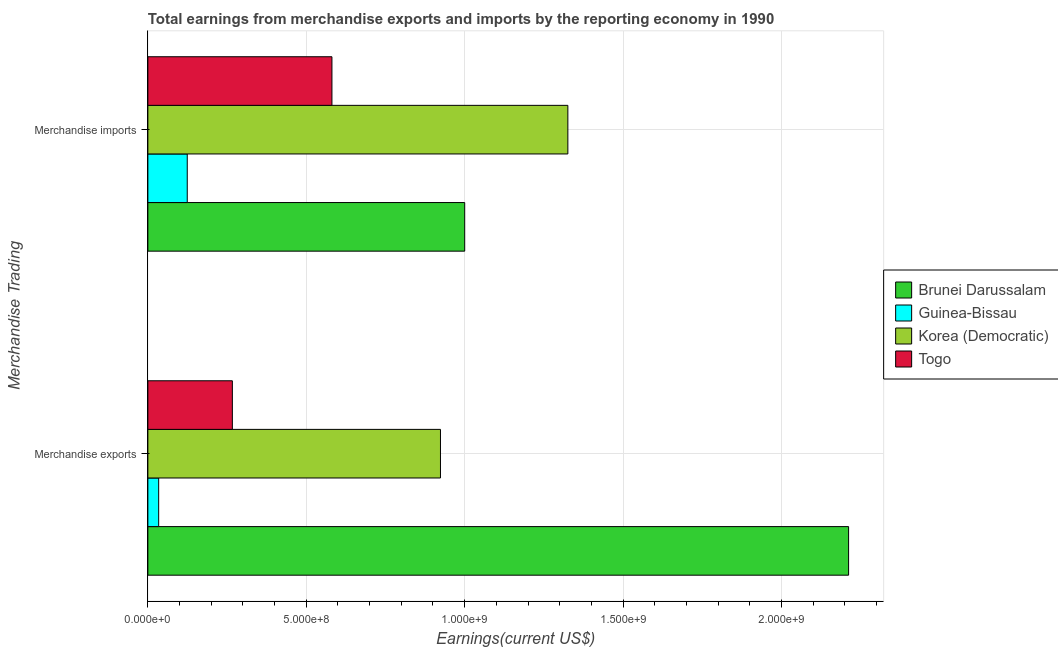How many groups of bars are there?
Provide a short and direct response. 2. Are the number of bars per tick equal to the number of legend labels?
Your answer should be compact. Yes. Are the number of bars on each tick of the Y-axis equal?
Give a very brief answer. Yes. How many bars are there on the 2nd tick from the top?
Your response must be concise. 4. How many bars are there on the 1st tick from the bottom?
Provide a short and direct response. 4. What is the earnings from merchandise exports in Togo?
Provide a succinct answer. 2.67e+08. Across all countries, what is the maximum earnings from merchandise exports?
Give a very brief answer. 2.21e+09. Across all countries, what is the minimum earnings from merchandise exports?
Provide a succinct answer. 3.41e+07. In which country was the earnings from merchandise exports maximum?
Your answer should be very brief. Brunei Darussalam. In which country was the earnings from merchandise exports minimum?
Give a very brief answer. Guinea-Bissau. What is the total earnings from merchandise exports in the graph?
Your answer should be very brief. 3.44e+09. What is the difference between the earnings from merchandise imports in Togo and that in Korea (Democratic)?
Keep it short and to the point. -7.45e+08. What is the difference between the earnings from merchandise imports in Guinea-Bissau and the earnings from merchandise exports in Brunei Darussalam?
Keep it short and to the point. -2.09e+09. What is the average earnings from merchandise imports per country?
Your response must be concise. 7.58e+08. What is the difference between the earnings from merchandise imports and earnings from merchandise exports in Brunei Darussalam?
Ensure brevity in your answer.  -1.21e+09. What is the ratio of the earnings from merchandise exports in Brunei Darussalam to that in Korea (Democratic)?
Your answer should be compact. 2.39. Is the earnings from merchandise imports in Brunei Darussalam less than that in Togo?
Keep it short and to the point. No. In how many countries, is the earnings from merchandise imports greater than the average earnings from merchandise imports taken over all countries?
Your answer should be compact. 2. What does the 4th bar from the top in Merchandise imports represents?
Provide a succinct answer. Brunei Darussalam. What does the 1st bar from the bottom in Merchandise exports represents?
Ensure brevity in your answer.  Brunei Darussalam. How many bars are there?
Ensure brevity in your answer.  8. Where does the legend appear in the graph?
Keep it short and to the point. Center right. How many legend labels are there?
Give a very brief answer. 4. What is the title of the graph?
Ensure brevity in your answer.  Total earnings from merchandise exports and imports by the reporting economy in 1990. Does "Serbia" appear as one of the legend labels in the graph?
Provide a succinct answer. No. What is the label or title of the X-axis?
Offer a terse response. Earnings(current US$). What is the label or title of the Y-axis?
Offer a very short reply. Merchandise Trading. What is the Earnings(current US$) of Brunei Darussalam in Merchandise exports?
Your response must be concise. 2.21e+09. What is the Earnings(current US$) in Guinea-Bissau in Merchandise exports?
Make the answer very short. 3.41e+07. What is the Earnings(current US$) of Korea (Democratic) in Merchandise exports?
Offer a terse response. 9.24e+08. What is the Earnings(current US$) in Togo in Merchandise exports?
Provide a succinct answer. 2.67e+08. What is the Earnings(current US$) of Brunei Darussalam in Merchandise imports?
Offer a terse response. 1.00e+09. What is the Earnings(current US$) of Guinea-Bissau in Merchandise imports?
Give a very brief answer. 1.24e+08. What is the Earnings(current US$) in Korea (Democratic) in Merchandise imports?
Your response must be concise. 1.33e+09. What is the Earnings(current US$) in Togo in Merchandise imports?
Your response must be concise. 5.81e+08. Across all Merchandise Trading, what is the maximum Earnings(current US$) in Brunei Darussalam?
Provide a short and direct response. 2.21e+09. Across all Merchandise Trading, what is the maximum Earnings(current US$) in Guinea-Bissau?
Keep it short and to the point. 1.24e+08. Across all Merchandise Trading, what is the maximum Earnings(current US$) of Korea (Democratic)?
Provide a succinct answer. 1.33e+09. Across all Merchandise Trading, what is the maximum Earnings(current US$) in Togo?
Offer a very short reply. 5.81e+08. Across all Merchandise Trading, what is the minimum Earnings(current US$) of Brunei Darussalam?
Make the answer very short. 1.00e+09. Across all Merchandise Trading, what is the minimum Earnings(current US$) of Guinea-Bissau?
Your answer should be compact. 3.41e+07. Across all Merchandise Trading, what is the minimum Earnings(current US$) of Korea (Democratic)?
Ensure brevity in your answer.  9.24e+08. Across all Merchandise Trading, what is the minimum Earnings(current US$) of Togo?
Offer a very short reply. 2.67e+08. What is the total Earnings(current US$) of Brunei Darussalam in the graph?
Your answer should be very brief. 3.21e+09. What is the total Earnings(current US$) of Guinea-Bissau in the graph?
Provide a short and direct response. 1.58e+08. What is the total Earnings(current US$) in Korea (Democratic) in the graph?
Give a very brief answer. 2.25e+09. What is the total Earnings(current US$) in Togo in the graph?
Make the answer very short. 8.48e+08. What is the difference between the Earnings(current US$) of Brunei Darussalam in Merchandise exports and that in Merchandise imports?
Give a very brief answer. 1.21e+09. What is the difference between the Earnings(current US$) of Guinea-Bissau in Merchandise exports and that in Merchandise imports?
Give a very brief answer. -9.02e+07. What is the difference between the Earnings(current US$) in Korea (Democratic) in Merchandise exports and that in Merchandise imports?
Keep it short and to the point. -4.02e+08. What is the difference between the Earnings(current US$) of Togo in Merchandise exports and that in Merchandise imports?
Provide a succinct answer. -3.14e+08. What is the difference between the Earnings(current US$) in Brunei Darussalam in Merchandise exports and the Earnings(current US$) in Guinea-Bissau in Merchandise imports?
Provide a succinct answer. 2.09e+09. What is the difference between the Earnings(current US$) of Brunei Darussalam in Merchandise exports and the Earnings(current US$) of Korea (Democratic) in Merchandise imports?
Your answer should be compact. 8.86e+08. What is the difference between the Earnings(current US$) in Brunei Darussalam in Merchandise exports and the Earnings(current US$) in Togo in Merchandise imports?
Your answer should be compact. 1.63e+09. What is the difference between the Earnings(current US$) in Guinea-Bissau in Merchandise exports and the Earnings(current US$) in Korea (Democratic) in Merchandise imports?
Give a very brief answer. -1.29e+09. What is the difference between the Earnings(current US$) of Guinea-Bissau in Merchandise exports and the Earnings(current US$) of Togo in Merchandise imports?
Keep it short and to the point. -5.47e+08. What is the difference between the Earnings(current US$) of Korea (Democratic) in Merchandise exports and the Earnings(current US$) of Togo in Merchandise imports?
Your response must be concise. 3.43e+08. What is the average Earnings(current US$) in Brunei Darussalam per Merchandise Trading?
Your answer should be compact. 1.61e+09. What is the average Earnings(current US$) in Guinea-Bissau per Merchandise Trading?
Give a very brief answer. 7.92e+07. What is the average Earnings(current US$) in Korea (Democratic) per Merchandise Trading?
Offer a very short reply. 1.12e+09. What is the average Earnings(current US$) in Togo per Merchandise Trading?
Provide a succinct answer. 4.24e+08. What is the difference between the Earnings(current US$) of Brunei Darussalam and Earnings(current US$) of Guinea-Bissau in Merchandise exports?
Offer a very short reply. 2.18e+09. What is the difference between the Earnings(current US$) in Brunei Darussalam and Earnings(current US$) in Korea (Democratic) in Merchandise exports?
Your answer should be very brief. 1.29e+09. What is the difference between the Earnings(current US$) of Brunei Darussalam and Earnings(current US$) of Togo in Merchandise exports?
Your response must be concise. 1.95e+09. What is the difference between the Earnings(current US$) of Guinea-Bissau and Earnings(current US$) of Korea (Democratic) in Merchandise exports?
Make the answer very short. -8.90e+08. What is the difference between the Earnings(current US$) in Guinea-Bissau and Earnings(current US$) in Togo in Merchandise exports?
Offer a terse response. -2.33e+08. What is the difference between the Earnings(current US$) of Korea (Democratic) and Earnings(current US$) of Togo in Merchandise exports?
Keep it short and to the point. 6.57e+08. What is the difference between the Earnings(current US$) of Brunei Darussalam and Earnings(current US$) of Guinea-Bissau in Merchandise imports?
Ensure brevity in your answer.  8.76e+08. What is the difference between the Earnings(current US$) of Brunei Darussalam and Earnings(current US$) of Korea (Democratic) in Merchandise imports?
Give a very brief answer. -3.26e+08. What is the difference between the Earnings(current US$) of Brunei Darussalam and Earnings(current US$) of Togo in Merchandise imports?
Provide a succinct answer. 4.19e+08. What is the difference between the Earnings(current US$) in Guinea-Bissau and Earnings(current US$) in Korea (Democratic) in Merchandise imports?
Provide a short and direct response. -1.20e+09. What is the difference between the Earnings(current US$) of Guinea-Bissau and Earnings(current US$) of Togo in Merchandise imports?
Your answer should be compact. -4.57e+08. What is the difference between the Earnings(current US$) in Korea (Democratic) and Earnings(current US$) in Togo in Merchandise imports?
Keep it short and to the point. 7.45e+08. What is the ratio of the Earnings(current US$) of Brunei Darussalam in Merchandise exports to that in Merchandise imports?
Your response must be concise. 2.21. What is the ratio of the Earnings(current US$) of Guinea-Bissau in Merchandise exports to that in Merchandise imports?
Your answer should be very brief. 0.27. What is the ratio of the Earnings(current US$) in Korea (Democratic) in Merchandise exports to that in Merchandise imports?
Make the answer very short. 0.7. What is the ratio of the Earnings(current US$) in Togo in Merchandise exports to that in Merchandise imports?
Offer a terse response. 0.46. What is the difference between the highest and the second highest Earnings(current US$) in Brunei Darussalam?
Provide a succinct answer. 1.21e+09. What is the difference between the highest and the second highest Earnings(current US$) in Guinea-Bissau?
Your response must be concise. 9.02e+07. What is the difference between the highest and the second highest Earnings(current US$) of Korea (Democratic)?
Offer a terse response. 4.02e+08. What is the difference between the highest and the second highest Earnings(current US$) of Togo?
Your response must be concise. 3.14e+08. What is the difference between the highest and the lowest Earnings(current US$) of Brunei Darussalam?
Provide a short and direct response. 1.21e+09. What is the difference between the highest and the lowest Earnings(current US$) in Guinea-Bissau?
Ensure brevity in your answer.  9.02e+07. What is the difference between the highest and the lowest Earnings(current US$) in Korea (Democratic)?
Provide a short and direct response. 4.02e+08. What is the difference between the highest and the lowest Earnings(current US$) in Togo?
Provide a short and direct response. 3.14e+08. 